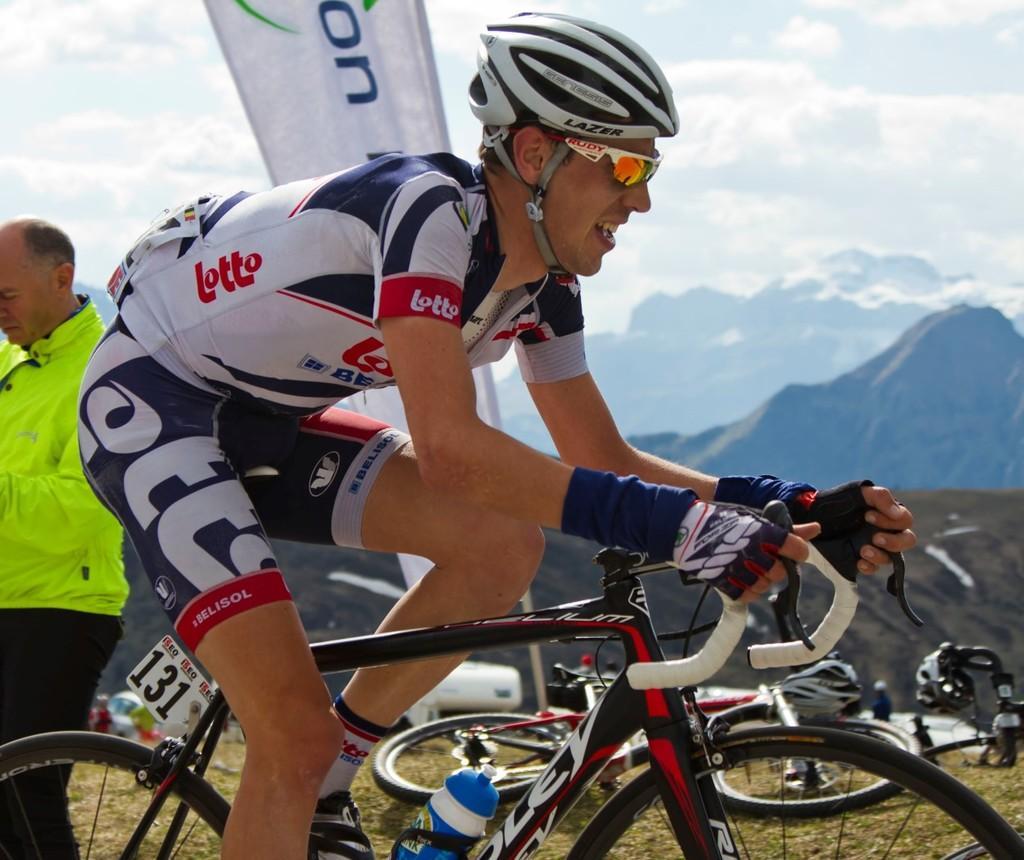How would you summarize this image in a sentence or two? A person wore a helmet and riding a bicycle. Background there are mountains, cloudy sky, bicycle, hoarding and person. To this bicycle there is a number board and bottle.  